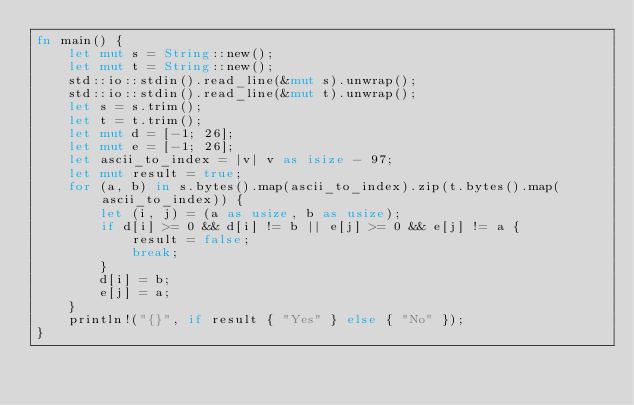Convert code to text. <code><loc_0><loc_0><loc_500><loc_500><_Rust_>fn main() {
    let mut s = String::new();
    let mut t = String::new();
    std::io::stdin().read_line(&mut s).unwrap();
    std::io::stdin().read_line(&mut t).unwrap();
    let s = s.trim();
    let t = t.trim();
    let mut d = [-1; 26];
    let mut e = [-1; 26];
    let ascii_to_index = |v| v as isize - 97;
    let mut result = true;
    for (a, b) in s.bytes().map(ascii_to_index).zip(t.bytes().map(ascii_to_index)) {
        let (i, j) = (a as usize, b as usize);
        if d[i] >= 0 && d[i] != b || e[j] >= 0 && e[j] != a {
            result = false;
            break;
        }
        d[i] = b;
        e[j] = a;
    }
    println!("{}", if result { "Yes" } else { "No" });
}
</code> 